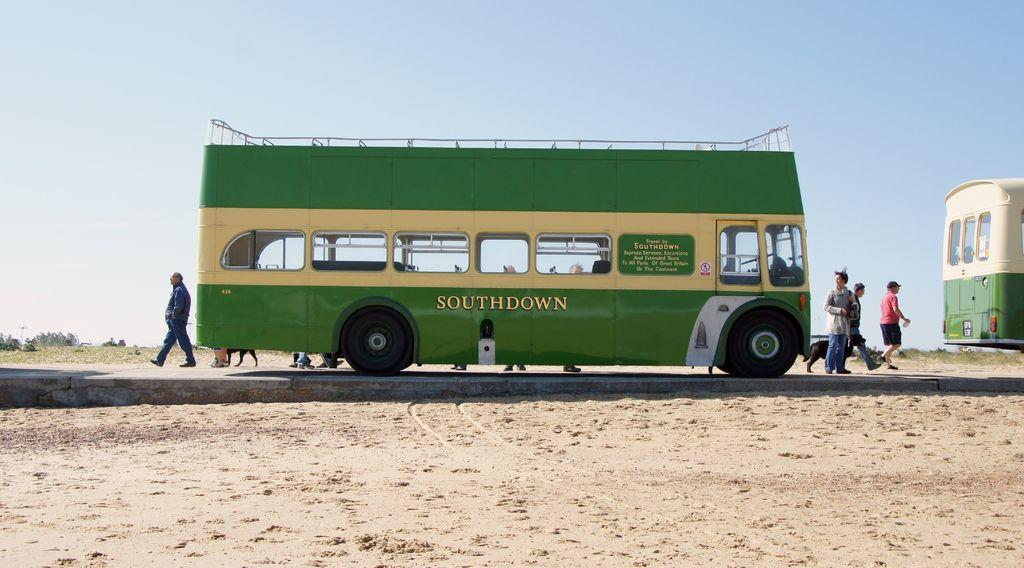<image>
Render a clear and concise summary of the photo. The green Southdown bus has a place on top for riders as well. 